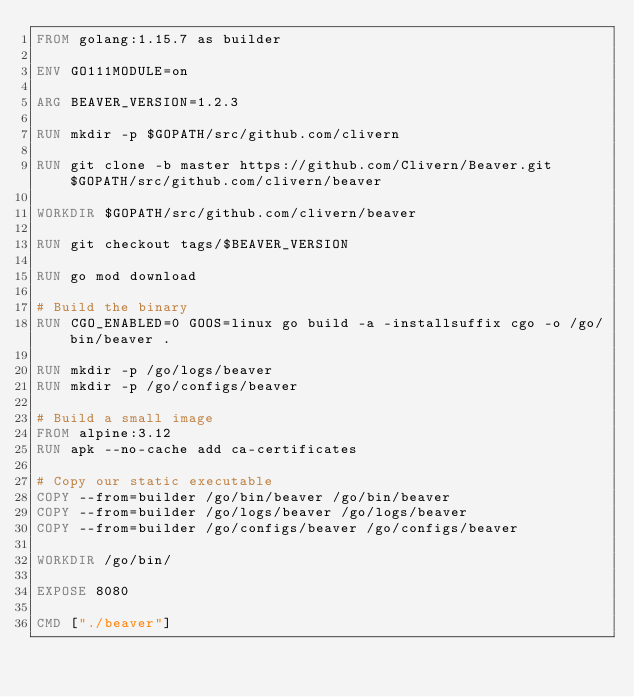<code> <loc_0><loc_0><loc_500><loc_500><_Dockerfile_>FROM golang:1.15.7 as builder

ENV GO111MODULE=on

ARG BEAVER_VERSION=1.2.3

RUN mkdir -p $GOPATH/src/github.com/clivern

RUN git clone -b master https://github.com/Clivern/Beaver.git $GOPATH/src/github.com/clivern/beaver

WORKDIR $GOPATH/src/github.com/clivern/beaver

RUN git checkout tags/$BEAVER_VERSION

RUN go mod download

# Build the binary
RUN CGO_ENABLED=0 GOOS=linux go build -a -installsuffix cgo -o /go/bin/beaver .

RUN mkdir -p /go/logs/beaver
RUN mkdir -p /go/configs/beaver

# Build a small image
FROM alpine:3.12
RUN apk --no-cache add ca-certificates

# Copy our static executable
COPY --from=builder /go/bin/beaver /go/bin/beaver
COPY --from=builder /go/logs/beaver /go/logs/beaver
COPY --from=builder /go/configs/beaver /go/configs/beaver

WORKDIR /go/bin/

EXPOSE 8080

CMD ["./beaver"]</code> 